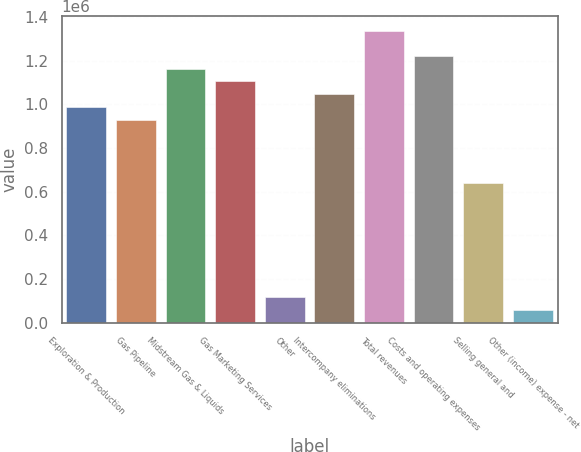Convert chart to OTSL. <chart><loc_0><loc_0><loc_500><loc_500><bar_chart><fcel>Exploration & Production<fcel>Gas Pipeline<fcel>Midstream Gas & Liquids<fcel>Gas Marketing Services<fcel>Other<fcel>Intercompany eliminations<fcel>Total revenues<fcel>Costs and operating expenses<fcel>Selling general and<fcel>Other (income) expense - net<nl><fcel>988845<fcel>930678<fcel>1.16335e+06<fcel>1.10518e+06<fcel>116336<fcel>1.04701e+06<fcel>1.33785e+06<fcel>1.22151e+06<fcel>639841<fcel>58168.3<nl></chart> 